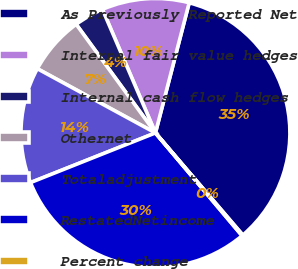Convert chart to OTSL. <chart><loc_0><loc_0><loc_500><loc_500><pie_chart><fcel>As Previously Reported Net<fcel>Internal fair value hedges<fcel>Internal cash flow hedges<fcel>Othernet<fcel>Totaladjustment<fcel>RestatedNetincome<fcel>Percent change<nl><fcel>34.7%<fcel>10.49%<fcel>3.58%<fcel>7.04%<fcel>13.95%<fcel>30.12%<fcel>0.12%<nl></chart> 